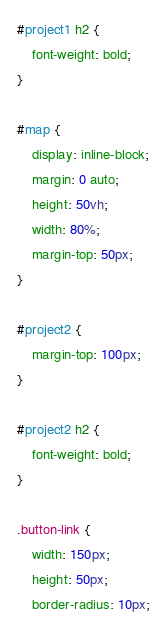Convert code to text. <code><loc_0><loc_0><loc_500><loc_500><_CSS_>#project1 h2 {
	font-weight: bold;
}

#map {
	display: inline-block;
	margin: 0 auto;
	height: 50vh;
    width: 80%;
    margin-top: 50px;
}

#project2 {
	margin-top: 100px;
}

#project2 h2 {
	font-weight: bold;
}

.button-link {
	width: 150px;
	height: 50px;
	border-radius: 10px;</code> 